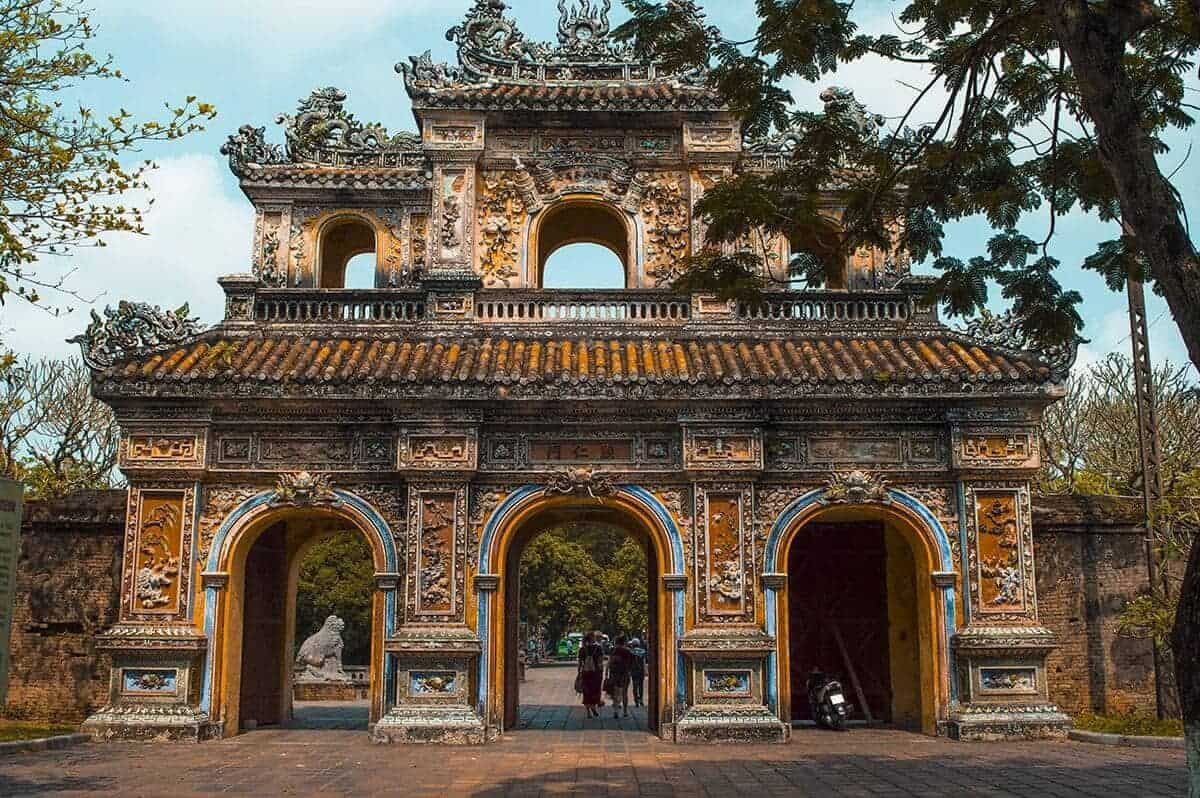What historical events took place at this location? The Imperial Citadel of Hue has been a witness to many significant events in Vietnamese history. Constructed in the early 19th century under the reign of Emperor Gia Long, it served as the cultural and political heart of the Nguyen Dynasty, the last royal dynasty of Vietnam. The citadel suffered considerable damage during the Vietnam War, particularly during the Tet Offensive of 1968, when it was a battleground between North Vietnamese forces and the South Vietnamese and American troops. The site has since been restored and remains a symbol of Vietnam's resilience. 